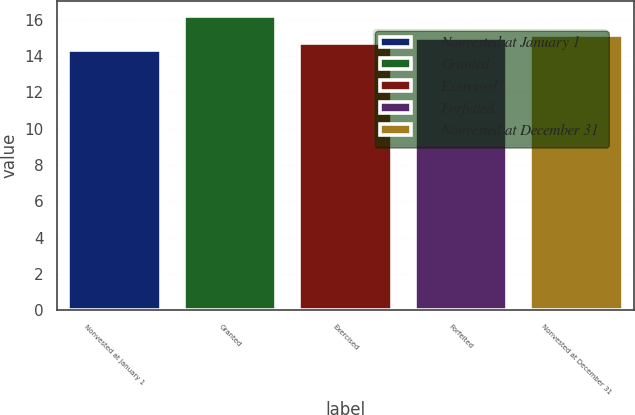<chart> <loc_0><loc_0><loc_500><loc_500><bar_chart><fcel>Nonvested at January 1<fcel>Granted<fcel>Exercised<fcel>Forfeited<fcel>Nonvested at December 31<nl><fcel>14.32<fcel>16.21<fcel>14.71<fcel>14.97<fcel>15.16<nl></chart> 